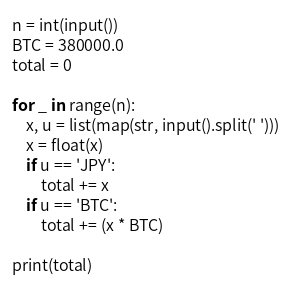Convert code to text. <code><loc_0><loc_0><loc_500><loc_500><_Python_>n = int(input())
BTC = 380000.0
total = 0

for _ in range(n):
    x, u = list(map(str, input().split(' ')))
    x = float(x)
    if u == 'JPY':
        total += x
    if u == 'BTC':
        total += (x * BTC)

print(total)
</code> 